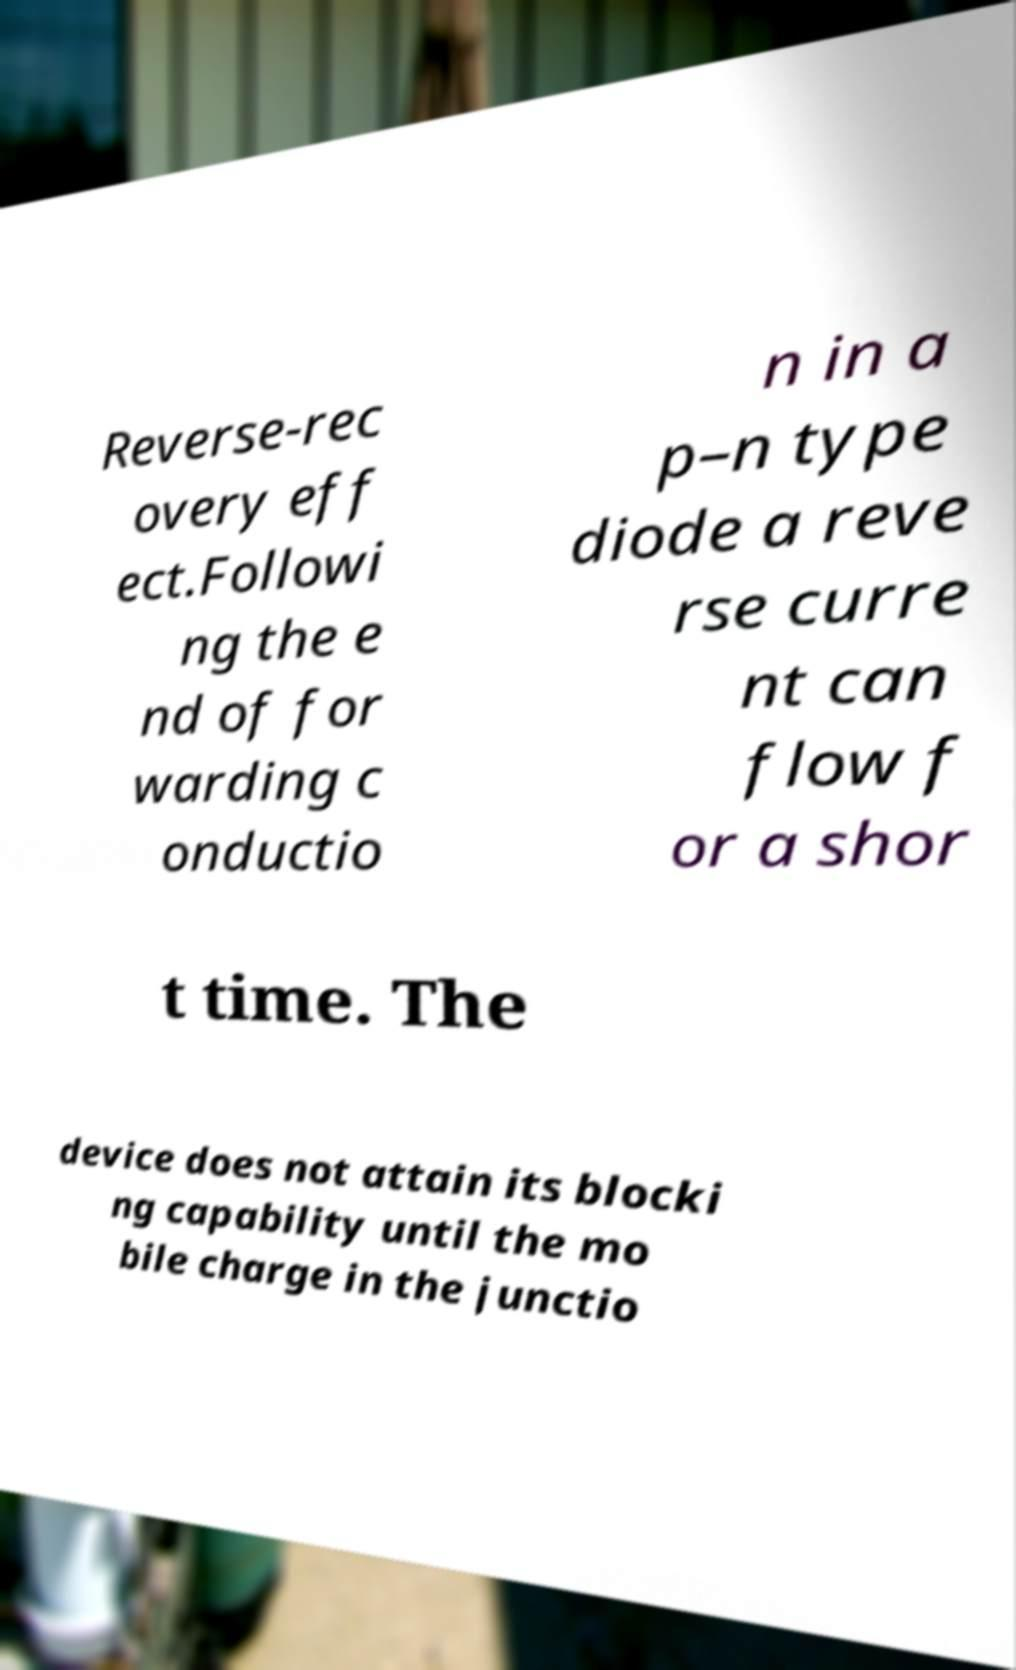There's text embedded in this image that I need extracted. Can you transcribe it verbatim? Reverse-rec overy eff ect.Followi ng the e nd of for warding c onductio n in a p–n type diode a reve rse curre nt can flow f or a shor t time. The device does not attain its blocki ng capability until the mo bile charge in the junctio 